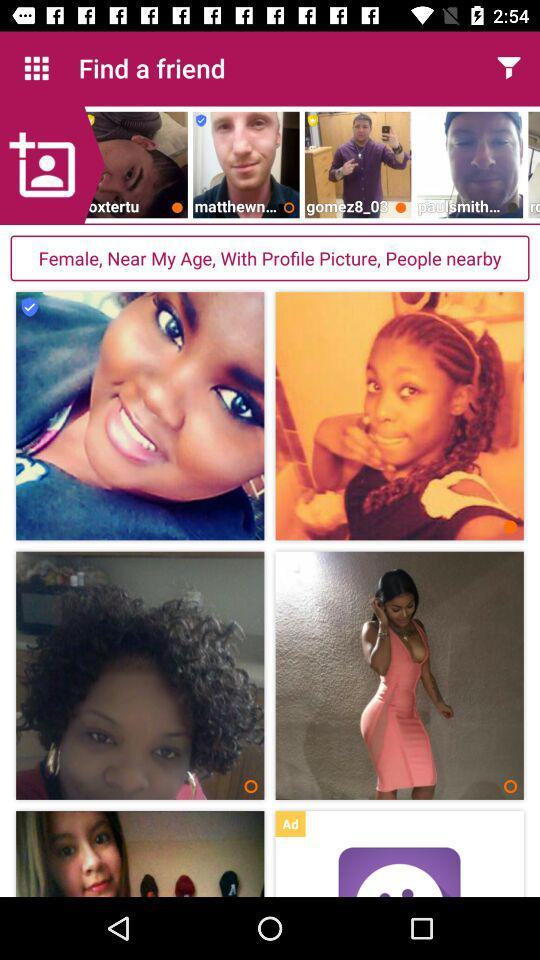For which gender is the person searching? The gender is female. 